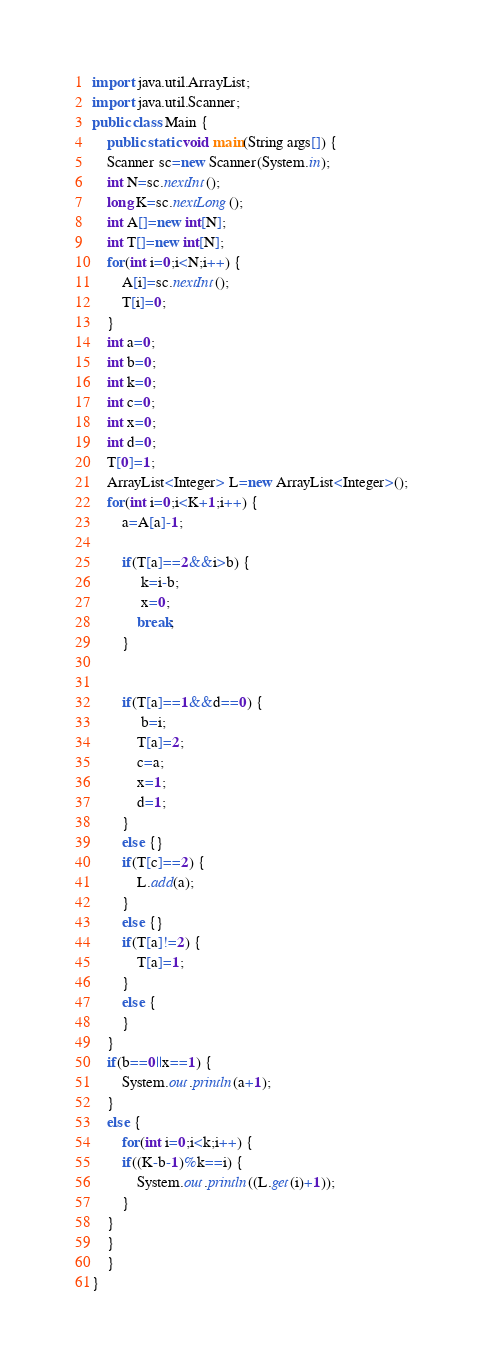Convert code to text. <code><loc_0><loc_0><loc_500><loc_500><_Java_>import java.util.ArrayList;
import java.util.Scanner;
public class Main {
	public static void main(String args[]) {
	Scanner sc=new Scanner(System.in);
	int N=sc.nextInt();
	long K=sc.nextLong();
	int A[]=new int[N];
	int T[]=new int[N];
	for(int i=0;i<N;i++) {
		A[i]=sc.nextInt();
		T[i]=0;
	}
	int a=0;
	int b=0;
	int k=0;
	int c=0;
	int x=0;
	int d=0;
	T[0]=1;
	ArrayList<Integer> L=new ArrayList<Integer>();
	for(int i=0;i<K+1;i++) {
		a=A[a]-1;
		
		if(T[a]==2&&i>b) {
			 k=i-b;
			 x=0;
			break;
		}
		
		
		if(T[a]==1&&d==0) {
			 b=i;
			T[a]=2;
			c=a;
			x=1;
			d=1;
		}
		else {}
		if(T[c]==2) {
			L.add(a);
		}
		else {}
		if(T[a]!=2) {
			T[a]=1;
		}
		else {	
		}
	}
	if(b==0||x==1) {
		System.out.println(a+1);
	}
	else {
		for(int i=0;i<k;i++) {
		if((K-b-1)%k==i) {
			System.out.println((L.get(i)+1));
		}
	}
	}
	}
}
</code> 